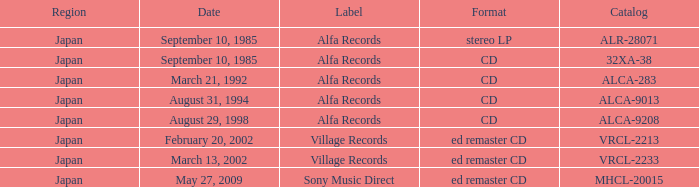Which identifier was recorded as alca-9013? Alfa Records. 